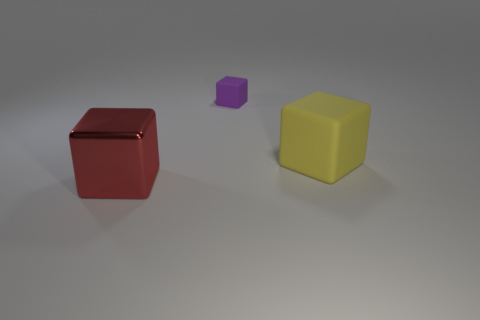Add 1 big yellow metallic cubes. How many objects exist? 4 Subtract 2 blocks. How many blocks are left? 1 Subtract all red cubes. How many cubes are left? 2 Subtract all red blocks. How many blocks are left? 2 Subtract all green cubes. Subtract all yellow spheres. How many cubes are left? 3 Subtract all blue cylinders. How many green blocks are left? 0 Subtract all yellow blocks. Subtract all purple objects. How many objects are left? 1 Add 3 tiny rubber blocks. How many tiny rubber blocks are left? 4 Add 3 tiny cyan metallic cubes. How many tiny cyan metallic cubes exist? 3 Subtract 0 green cylinders. How many objects are left? 3 